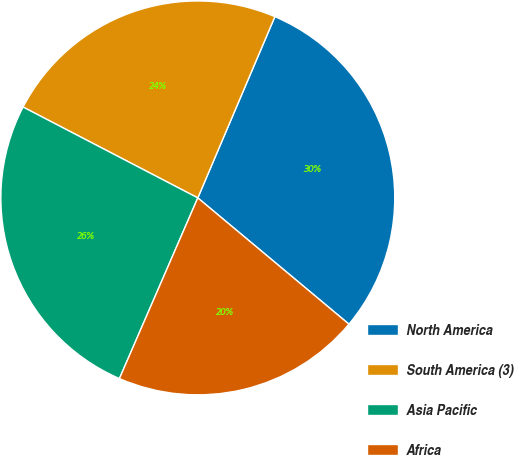<chart> <loc_0><loc_0><loc_500><loc_500><pie_chart><fcel>North America<fcel>South America (3)<fcel>Asia Pacific<fcel>Africa<nl><fcel>29.68%<fcel>23.77%<fcel>26.12%<fcel>20.44%<nl></chart> 